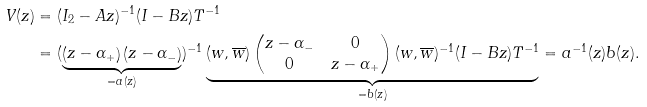<formula> <loc_0><loc_0><loc_500><loc_500>V ( z ) & = ( I _ { 2 } - A z ) ^ { - 1 } ( I - B z ) T ^ { - 1 } \\ & = ( \underbrace { \left ( z - \alpha _ { + } \right ) \left ( z - \alpha _ { - } \right ) } _ { = a ( z ) } ) ^ { - 1 } \underbrace { ( w , \overline { w } ) \begin{pmatrix} z - \alpha _ { - } & 0 \\ 0 & z - \alpha _ { + } \end{pmatrix} ( w , \overline { w } ) ^ { - 1 } ( I - B z ) T ^ { - 1 } } _ { = b ( z ) } = a ^ { - 1 } ( z ) b ( z ) .</formula> 